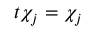<formula> <loc_0><loc_0><loc_500><loc_500>t \chi _ { j } = \chi _ { j }</formula> 